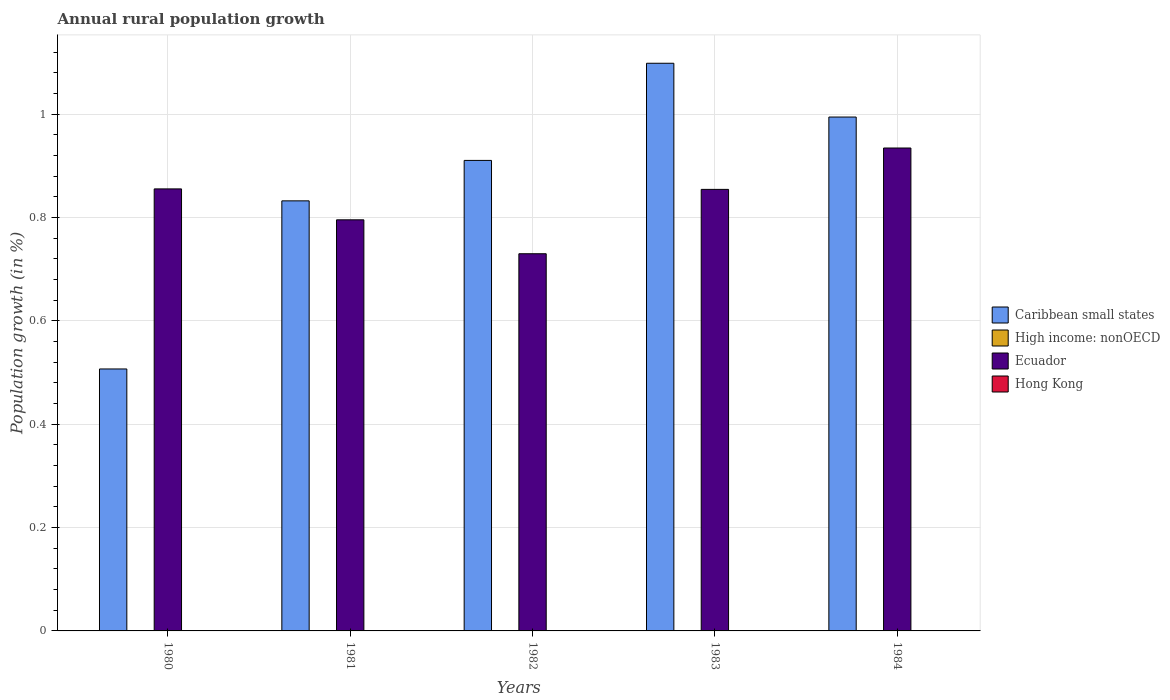Are the number of bars per tick equal to the number of legend labels?
Provide a succinct answer. No. Are the number of bars on each tick of the X-axis equal?
Provide a succinct answer. Yes. What is the percentage of rural population growth in Hong Kong in 1982?
Your answer should be compact. 0. Across all years, what is the maximum percentage of rural population growth in Caribbean small states?
Make the answer very short. 1.1. In which year was the percentage of rural population growth in Caribbean small states maximum?
Ensure brevity in your answer.  1983. What is the total percentage of rural population growth in Ecuador in the graph?
Ensure brevity in your answer.  4.17. What is the difference between the percentage of rural population growth in Ecuador in 1980 and that in 1981?
Ensure brevity in your answer.  0.06. What is the difference between the percentage of rural population growth in Ecuador in 1981 and the percentage of rural population growth in Caribbean small states in 1984?
Offer a terse response. -0.2. In the year 1980, what is the difference between the percentage of rural population growth in Caribbean small states and percentage of rural population growth in Ecuador?
Your response must be concise. -0.35. In how many years, is the percentage of rural population growth in High income: nonOECD greater than 0.2 %?
Your response must be concise. 0. What is the ratio of the percentage of rural population growth in Caribbean small states in 1981 to that in 1982?
Make the answer very short. 0.91. What is the difference between the highest and the second highest percentage of rural population growth in Ecuador?
Provide a short and direct response. 0.08. What is the difference between the highest and the lowest percentage of rural population growth in Ecuador?
Provide a short and direct response. 0.2. In how many years, is the percentage of rural population growth in Hong Kong greater than the average percentage of rural population growth in Hong Kong taken over all years?
Give a very brief answer. 0. Is the sum of the percentage of rural population growth in Caribbean small states in 1980 and 1981 greater than the maximum percentage of rural population growth in Ecuador across all years?
Keep it short and to the point. Yes. Is it the case that in every year, the sum of the percentage of rural population growth in Ecuador and percentage of rural population growth in High income: nonOECD is greater than the percentage of rural population growth in Hong Kong?
Make the answer very short. Yes. How many bars are there?
Give a very brief answer. 10. How many years are there in the graph?
Offer a terse response. 5. What is the difference between two consecutive major ticks on the Y-axis?
Your answer should be very brief. 0.2. Does the graph contain any zero values?
Provide a succinct answer. Yes. What is the title of the graph?
Give a very brief answer. Annual rural population growth. What is the label or title of the X-axis?
Give a very brief answer. Years. What is the label or title of the Y-axis?
Ensure brevity in your answer.  Population growth (in %). What is the Population growth (in %) of Caribbean small states in 1980?
Your response must be concise. 0.51. What is the Population growth (in %) in Ecuador in 1980?
Provide a short and direct response. 0.86. What is the Population growth (in %) in Hong Kong in 1980?
Provide a short and direct response. 0. What is the Population growth (in %) of Caribbean small states in 1981?
Your response must be concise. 0.83. What is the Population growth (in %) of High income: nonOECD in 1981?
Provide a short and direct response. 0. What is the Population growth (in %) in Ecuador in 1981?
Ensure brevity in your answer.  0.8. What is the Population growth (in %) in Caribbean small states in 1982?
Your answer should be compact. 0.91. What is the Population growth (in %) of Ecuador in 1982?
Your answer should be compact. 0.73. What is the Population growth (in %) of Hong Kong in 1982?
Provide a succinct answer. 0. What is the Population growth (in %) in Caribbean small states in 1983?
Ensure brevity in your answer.  1.1. What is the Population growth (in %) of High income: nonOECD in 1983?
Your response must be concise. 0. What is the Population growth (in %) of Ecuador in 1983?
Provide a short and direct response. 0.85. What is the Population growth (in %) in Caribbean small states in 1984?
Give a very brief answer. 0.99. What is the Population growth (in %) of Ecuador in 1984?
Your response must be concise. 0.93. What is the Population growth (in %) in Hong Kong in 1984?
Offer a very short reply. 0. Across all years, what is the maximum Population growth (in %) in Caribbean small states?
Your answer should be very brief. 1.1. Across all years, what is the maximum Population growth (in %) of Ecuador?
Make the answer very short. 0.93. Across all years, what is the minimum Population growth (in %) in Caribbean small states?
Your answer should be very brief. 0.51. Across all years, what is the minimum Population growth (in %) of Ecuador?
Provide a succinct answer. 0.73. What is the total Population growth (in %) of Caribbean small states in the graph?
Provide a succinct answer. 4.34. What is the total Population growth (in %) of Ecuador in the graph?
Your answer should be very brief. 4.17. What is the difference between the Population growth (in %) in Caribbean small states in 1980 and that in 1981?
Provide a short and direct response. -0.33. What is the difference between the Population growth (in %) of Ecuador in 1980 and that in 1981?
Your answer should be compact. 0.06. What is the difference between the Population growth (in %) in Caribbean small states in 1980 and that in 1982?
Your answer should be very brief. -0.4. What is the difference between the Population growth (in %) in Ecuador in 1980 and that in 1982?
Offer a terse response. 0.13. What is the difference between the Population growth (in %) of Caribbean small states in 1980 and that in 1983?
Give a very brief answer. -0.59. What is the difference between the Population growth (in %) of Ecuador in 1980 and that in 1983?
Your answer should be very brief. 0. What is the difference between the Population growth (in %) in Caribbean small states in 1980 and that in 1984?
Your response must be concise. -0.49. What is the difference between the Population growth (in %) of Ecuador in 1980 and that in 1984?
Your answer should be very brief. -0.08. What is the difference between the Population growth (in %) of Caribbean small states in 1981 and that in 1982?
Make the answer very short. -0.08. What is the difference between the Population growth (in %) in Ecuador in 1981 and that in 1982?
Provide a short and direct response. 0.07. What is the difference between the Population growth (in %) in Caribbean small states in 1981 and that in 1983?
Your answer should be very brief. -0.27. What is the difference between the Population growth (in %) in Ecuador in 1981 and that in 1983?
Give a very brief answer. -0.06. What is the difference between the Population growth (in %) in Caribbean small states in 1981 and that in 1984?
Keep it short and to the point. -0.16. What is the difference between the Population growth (in %) in Ecuador in 1981 and that in 1984?
Your answer should be very brief. -0.14. What is the difference between the Population growth (in %) in Caribbean small states in 1982 and that in 1983?
Your answer should be very brief. -0.19. What is the difference between the Population growth (in %) in Ecuador in 1982 and that in 1983?
Keep it short and to the point. -0.12. What is the difference between the Population growth (in %) in Caribbean small states in 1982 and that in 1984?
Give a very brief answer. -0.08. What is the difference between the Population growth (in %) of Ecuador in 1982 and that in 1984?
Give a very brief answer. -0.2. What is the difference between the Population growth (in %) in Caribbean small states in 1983 and that in 1984?
Offer a very short reply. 0.1. What is the difference between the Population growth (in %) in Ecuador in 1983 and that in 1984?
Make the answer very short. -0.08. What is the difference between the Population growth (in %) in Caribbean small states in 1980 and the Population growth (in %) in Ecuador in 1981?
Your answer should be compact. -0.29. What is the difference between the Population growth (in %) in Caribbean small states in 1980 and the Population growth (in %) in Ecuador in 1982?
Your answer should be very brief. -0.22. What is the difference between the Population growth (in %) in Caribbean small states in 1980 and the Population growth (in %) in Ecuador in 1983?
Provide a short and direct response. -0.35. What is the difference between the Population growth (in %) of Caribbean small states in 1980 and the Population growth (in %) of Ecuador in 1984?
Provide a succinct answer. -0.43. What is the difference between the Population growth (in %) in Caribbean small states in 1981 and the Population growth (in %) in Ecuador in 1982?
Ensure brevity in your answer.  0.1. What is the difference between the Population growth (in %) in Caribbean small states in 1981 and the Population growth (in %) in Ecuador in 1983?
Make the answer very short. -0.02. What is the difference between the Population growth (in %) of Caribbean small states in 1981 and the Population growth (in %) of Ecuador in 1984?
Give a very brief answer. -0.1. What is the difference between the Population growth (in %) in Caribbean small states in 1982 and the Population growth (in %) in Ecuador in 1983?
Give a very brief answer. 0.06. What is the difference between the Population growth (in %) in Caribbean small states in 1982 and the Population growth (in %) in Ecuador in 1984?
Give a very brief answer. -0.02. What is the difference between the Population growth (in %) of Caribbean small states in 1983 and the Population growth (in %) of Ecuador in 1984?
Provide a succinct answer. 0.16. What is the average Population growth (in %) of Caribbean small states per year?
Your answer should be very brief. 0.87. What is the average Population growth (in %) of Ecuador per year?
Your answer should be compact. 0.83. What is the average Population growth (in %) in Hong Kong per year?
Offer a terse response. 0. In the year 1980, what is the difference between the Population growth (in %) in Caribbean small states and Population growth (in %) in Ecuador?
Make the answer very short. -0.35. In the year 1981, what is the difference between the Population growth (in %) in Caribbean small states and Population growth (in %) in Ecuador?
Your response must be concise. 0.04. In the year 1982, what is the difference between the Population growth (in %) of Caribbean small states and Population growth (in %) of Ecuador?
Ensure brevity in your answer.  0.18. In the year 1983, what is the difference between the Population growth (in %) in Caribbean small states and Population growth (in %) in Ecuador?
Give a very brief answer. 0.24. In the year 1984, what is the difference between the Population growth (in %) of Caribbean small states and Population growth (in %) of Ecuador?
Make the answer very short. 0.06. What is the ratio of the Population growth (in %) of Caribbean small states in 1980 to that in 1981?
Make the answer very short. 0.61. What is the ratio of the Population growth (in %) of Ecuador in 1980 to that in 1981?
Provide a succinct answer. 1.08. What is the ratio of the Population growth (in %) in Caribbean small states in 1980 to that in 1982?
Ensure brevity in your answer.  0.56. What is the ratio of the Population growth (in %) of Ecuador in 1980 to that in 1982?
Your answer should be very brief. 1.17. What is the ratio of the Population growth (in %) in Caribbean small states in 1980 to that in 1983?
Keep it short and to the point. 0.46. What is the ratio of the Population growth (in %) of Caribbean small states in 1980 to that in 1984?
Keep it short and to the point. 0.51. What is the ratio of the Population growth (in %) in Ecuador in 1980 to that in 1984?
Your answer should be compact. 0.92. What is the ratio of the Population growth (in %) of Caribbean small states in 1981 to that in 1982?
Your answer should be compact. 0.91. What is the ratio of the Population growth (in %) of Ecuador in 1981 to that in 1982?
Give a very brief answer. 1.09. What is the ratio of the Population growth (in %) in Caribbean small states in 1981 to that in 1983?
Provide a succinct answer. 0.76. What is the ratio of the Population growth (in %) in Ecuador in 1981 to that in 1983?
Your response must be concise. 0.93. What is the ratio of the Population growth (in %) in Caribbean small states in 1981 to that in 1984?
Your answer should be very brief. 0.84. What is the ratio of the Population growth (in %) in Ecuador in 1981 to that in 1984?
Keep it short and to the point. 0.85. What is the ratio of the Population growth (in %) in Caribbean small states in 1982 to that in 1983?
Offer a very short reply. 0.83. What is the ratio of the Population growth (in %) of Ecuador in 1982 to that in 1983?
Your answer should be compact. 0.85. What is the ratio of the Population growth (in %) in Caribbean small states in 1982 to that in 1984?
Give a very brief answer. 0.92. What is the ratio of the Population growth (in %) in Ecuador in 1982 to that in 1984?
Provide a short and direct response. 0.78. What is the ratio of the Population growth (in %) of Caribbean small states in 1983 to that in 1984?
Ensure brevity in your answer.  1.1. What is the ratio of the Population growth (in %) of Ecuador in 1983 to that in 1984?
Provide a short and direct response. 0.91. What is the difference between the highest and the second highest Population growth (in %) of Caribbean small states?
Provide a succinct answer. 0.1. What is the difference between the highest and the second highest Population growth (in %) in Ecuador?
Provide a short and direct response. 0.08. What is the difference between the highest and the lowest Population growth (in %) of Caribbean small states?
Your answer should be very brief. 0.59. What is the difference between the highest and the lowest Population growth (in %) of Ecuador?
Offer a terse response. 0.2. 